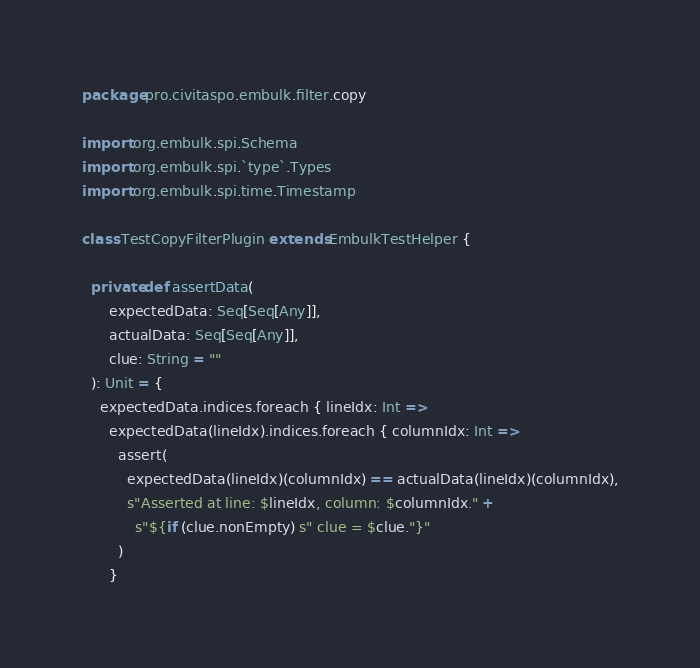<code> <loc_0><loc_0><loc_500><loc_500><_Scala_>package pro.civitaspo.embulk.filter.copy

import org.embulk.spi.Schema
import org.embulk.spi.`type`.Types
import org.embulk.spi.time.Timestamp

class TestCopyFilterPlugin extends EmbulkTestHelper {

  private def assertData(
      expectedData: Seq[Seq[Any]],
      actualData: Seq[Seq[Any]],
      clue: String = ""
  ): Unit = {
    expectedData.indices.foreach { lineIdx: Int =>
      expectedData(lineIdx).indices.foreach { columnIdx: Int =>
        assert(
          expectedData(lineIdx)(columnIdx) == actualData(lineIdx)(columnIdx),
          s"Asserted at line: $lineIdx, column: $columnIdx." +
            s"${if (clue.nonEmpty) s" clue = $clue."}"
        )
      }</code> 